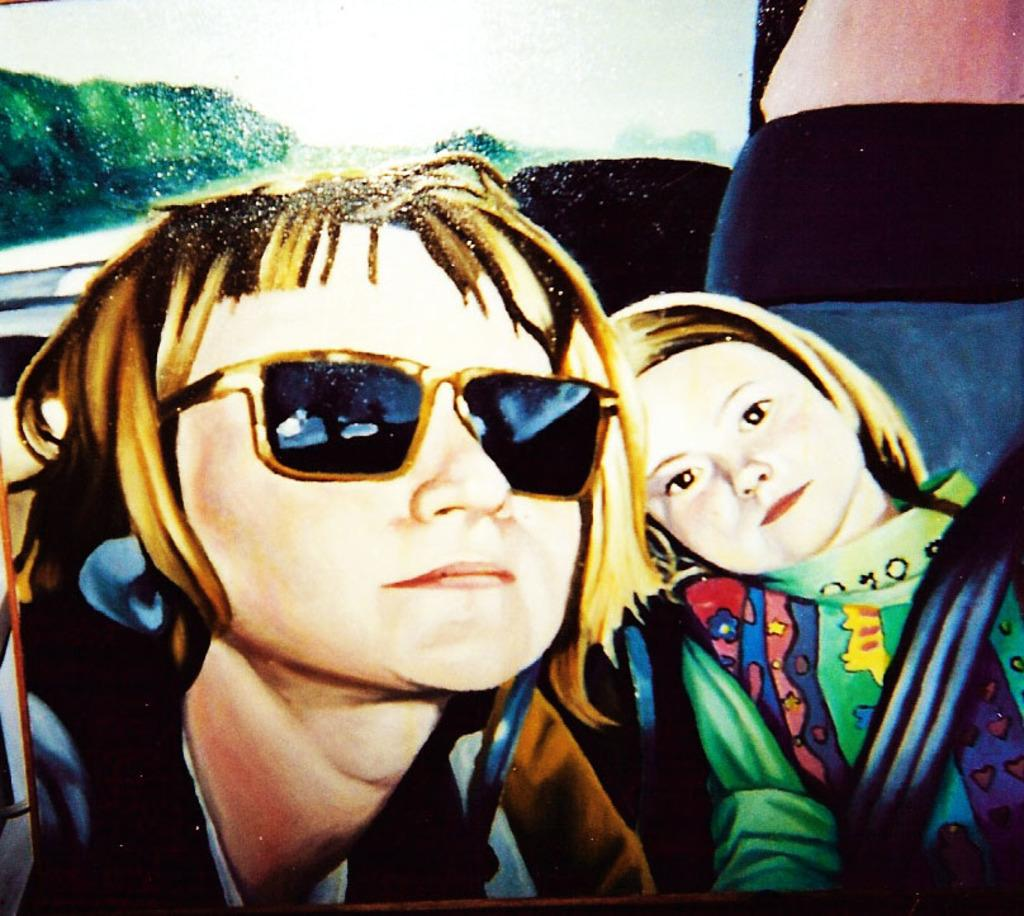What is the main subject of the image? There is a painting in the image. What type of discovery was made during the operation depicted in the painting? There is no operation or discovery depicted in the painting, as it only features a painting as the main subject. 